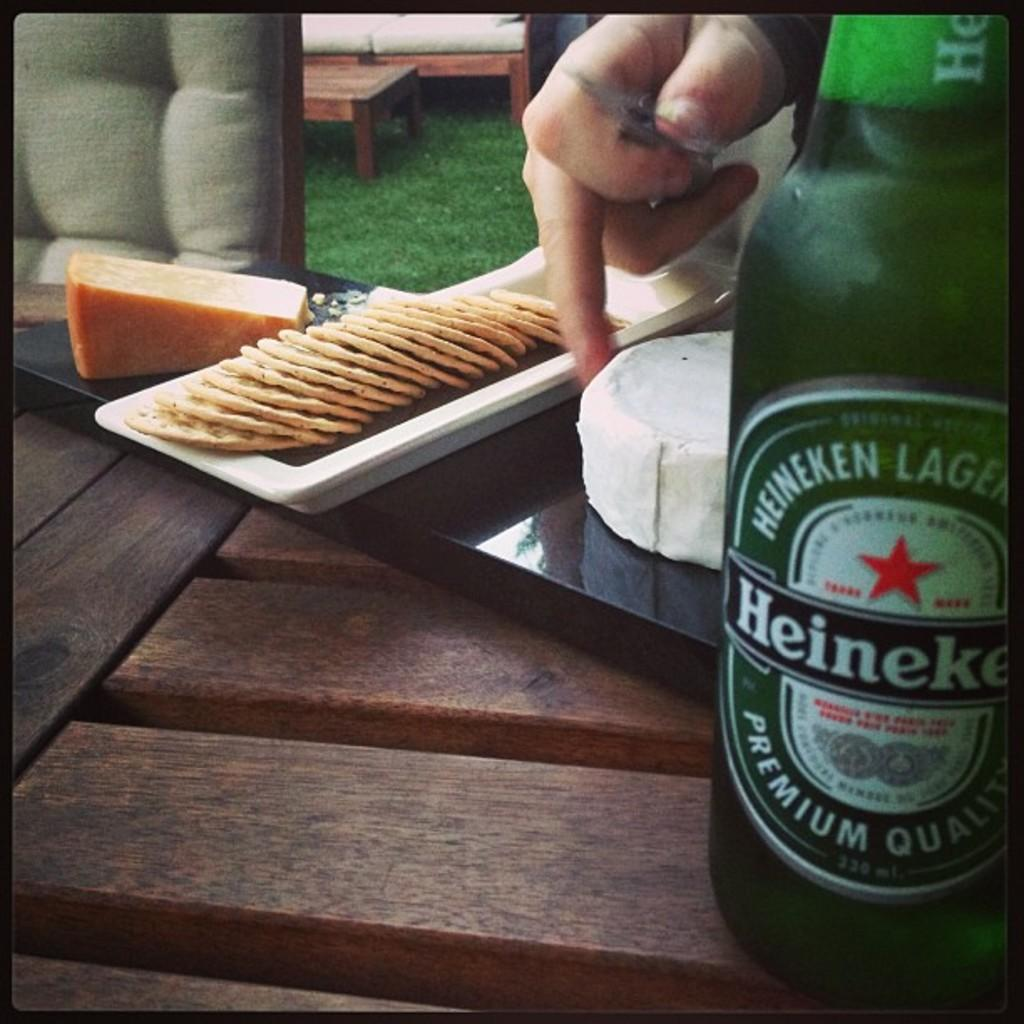<image>
Summarize the visual content of the image. A tray of cheese and crackers is arranged next to a bottle of Heineken Lager. 